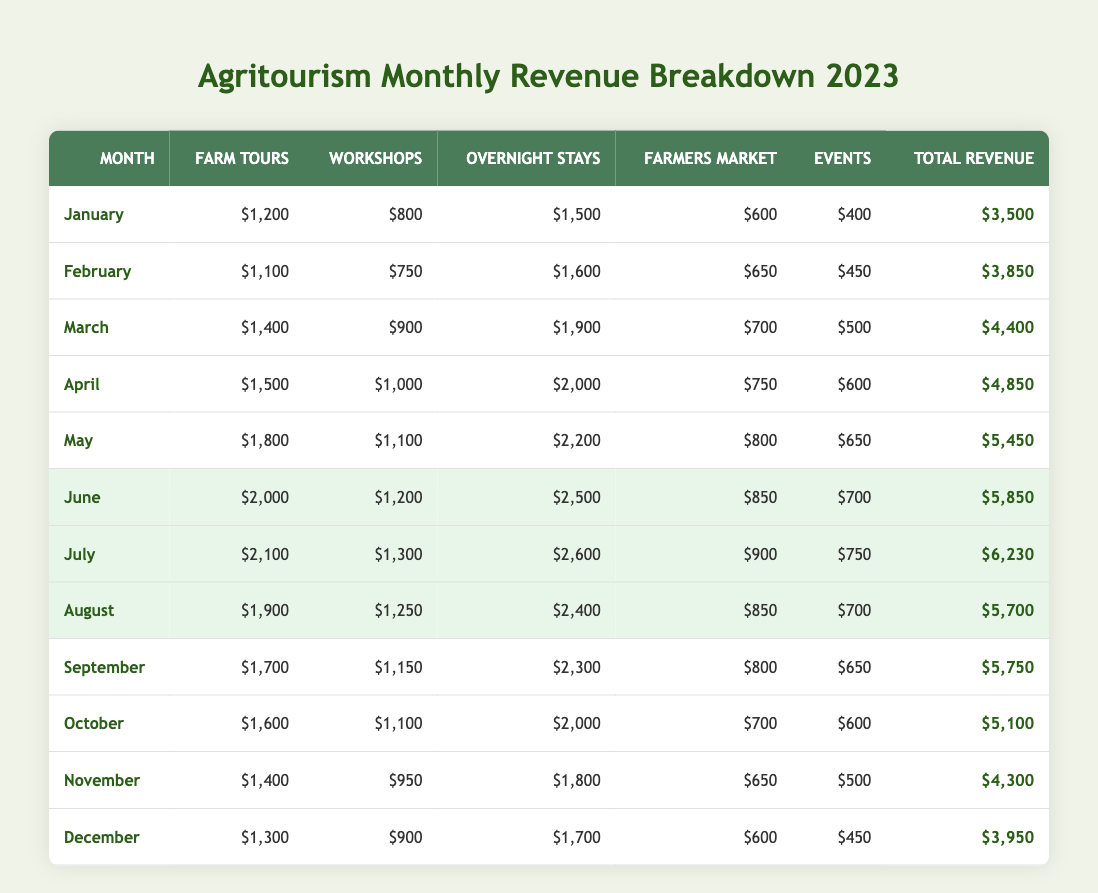What was the total revenue for July? To find the total revenue for July, we look at the row for July in the table. The total revenue listed is $6,230.
Answer: $6,230 Which month had the highest revenue from overnight stays? We compare the overnight stay revenues across all months. The highest amount is $2,600 in July.
Answer: $2,600 How much revenue did farm tours generate in February? The table shows that farm tours generated $1,100 in February.
Answer: $1,100 What was the average total revenue for the months of January to March? First, we calculate the total revenue for January, February, and March: $3,500 + $3,850 + $4,400 = $11,750. Then, we divide by 3 (the number of months): $11,750 / 3 = $3,916.67.
Answer: $3,916.67 Did the revenue from workshops increase every month? We check the workshop revenue for each month. The values are: $800 (Jan), $750 (Feb), $900 (Mar), $1,000 (Apr), $1,100 (May), $1,200 (Jun), $1,300 (Jul), $1,250 (Aug), $1,150 (Sep), $1,100 (Oct), $950 (Nov), $900 (Dec). The revenue decreased from January to February, so it did not increase every month.
Answer: No What is the total revenue for the second half of the year (July to December)? We sum the total revenues from July to December: $6,230 + $5,700 + $5,750 + $5,100 + $4,300 + $3,950 = $36,030.
Answer: $36,030 In which month was the difference between total revenue and farm tours revenue the largest? We need to compute the difference for each month and identify the largest. The differences are: Jan: $2,300, Feb: $2,750, Mar: $3,000, Apr: $3,350, May: $3,650, Jun: $3,850, July: $4,130, August: $3,800, September: $4,050, October: $3,500, November: $2,900, December: $2,650. The largest difference is $4,130 in July.
Answer: July What is the total revenue from farmers markets for the year? We sum the farmers market revenues for each month: $600 + $650 + $700 + $750 + $800 + $850 + $900 + $850 + $800 + $700 + $650 + $600 = $9,450.
Answer: $9,450 Which month saw the least revenue from events? We look at the event revenue for each month: $400 (Jan), $450 (Feb), $500 (Mar), $600 (Apr), $650 (May), $700 (Jun), $750 (Jul), $700 (Aug), $650 (Sep), $600 (Oct), $500 (Nov), $450 (Dec). The lowest is $400 in January.
Answer: January What was the total revenue for the months of August and September combined? We sum the total revenues for August and September: $5,700 + $5,750 = $11,450.
Answer: $11,450 